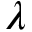Convert formula to latex. <formula><loc_0><loc_0><loc_500><loc_500>\lambda</formula> 